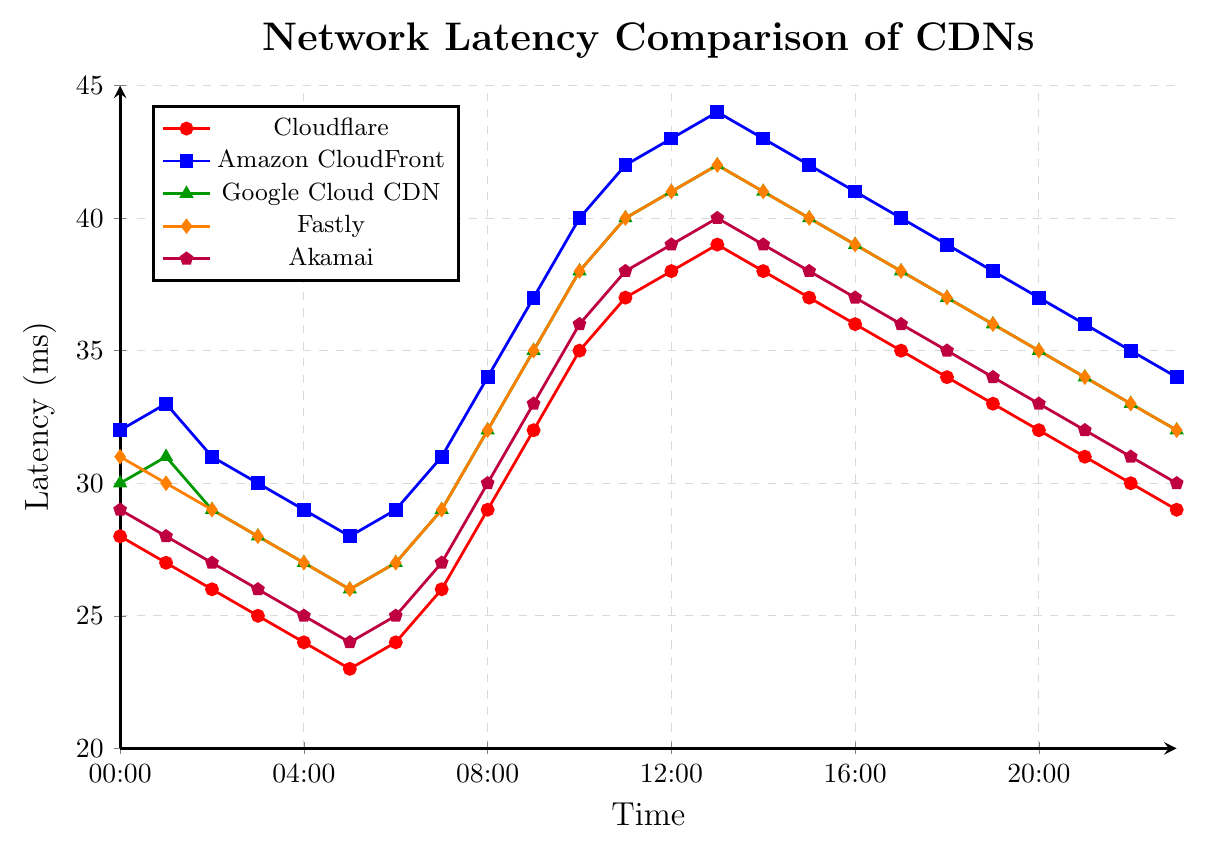What's the peak latency for Cloudflare? The line for Cloudflare starts at 28 ms at 00:00 and generally increases until it peaks at 39 ms at 13:00. It then decreases again.
Answer: 39 ms At what time does Amazon CloudFront have the lowest latency? The line for Amazon CloudFront shows the lowest value at 05:00 with a latency of 28 ms.
Answer: 05:00 Which CDN has the highest latency at 12:00? By examining the lines at 12:00, Amazon CloudFront has the highest latency at 43 ms compared to the others.
Answer: Amazon CloudFront What's the general trend in latency for Akamai over the 24-hour period? The line for Akamai starts at 29 ms at 00:00, decreases to 24 ms at 05:00, then steadily increases to 40 ms at 13:00, and slightly decreases afterward.
Answer: Decreasing, then increasing Compare the latency between Google Cloud CDN and Fastly at 11:00. Which one is higher? Both Google Cloud CDN and Fastly have a latency of 40 ms at 11:00.
Answer: Equal latency What's the average latency of Cloudflare between 00:00 and 23:00? Sum the latencies for Cloudflare at each hour (28+27+26+25+24+23+24+26+29+32+35+37+38+39+38+37+36+35+34+33+32+31+30+29) to get 690 ms. Divide by 24 hours.
Answer: 28.75 ms Which CDN shows the most stability in its latency over the 24-hour period? By comparing the fluctuations of each line, Akamai shows the least amount of fluctuation and thus the most stability.
Answer: Akamai How does Cloudflare's latency at 16:00 compare to Fastly's latency at the same time? Cloudflare has a latency of 36 ms at 16:00, compared to Fastly's latency of 39 ms at the same time.
Answer: Cloudflare's is lower At what time do all the CDNs show the same latency trend, either all increasing or all decreasing? All CDNs show an increasing latency trend from 08:00 till around 13:00 and a decreasing trend afterwards.
Answer: 08:00-13:00 